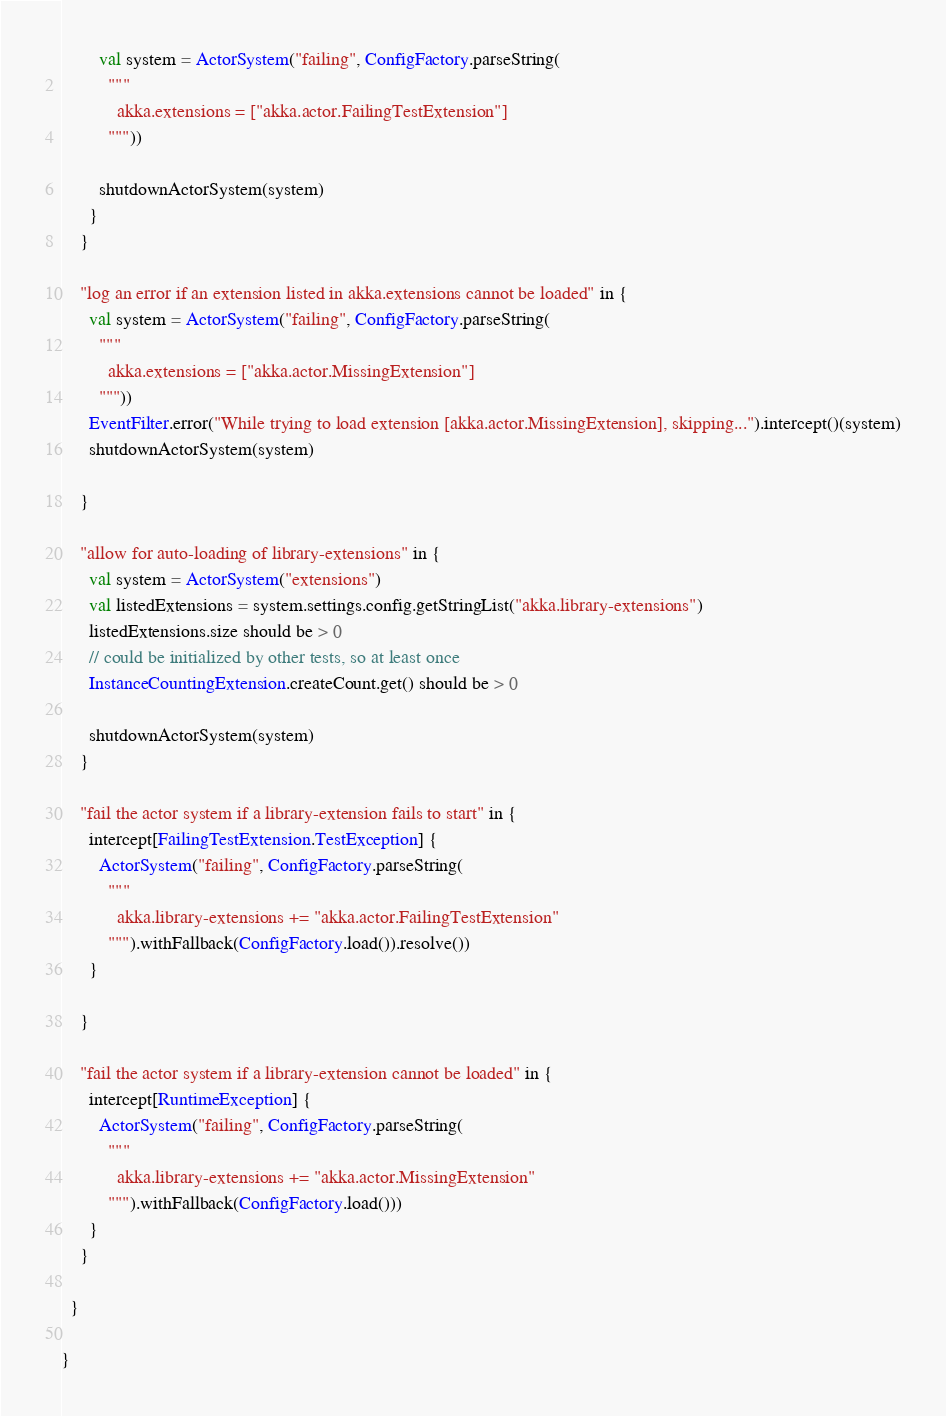<code> <loc_0><loc_0><loc_500><loc_500><_Scala_>        val system = ActorSystem("failing", ConfigFactory.parseString(
          """
            akka.extensions = ["akka.actor.FailingTestExtension"]
          """))

        shutdownActorSystem(system)
      }
    }

    "log an error if an extension listed in akka.extensions cannot be loaded" in {
      val system = ActorSystem("failing", ConfigFactory.parseString(
        """
          akka.extensions = ["akka.actor.MissingExtension"]
        """))
      EventFilter.error("While trying to load extension [akka.actor.MissingExtension], skipping...").intercept()(system)
      shutdownActorSystem(system)

    }

    "allow for auto-loading of library-extensions" in {
      val system = ActorSystem("extensions")
      val listedExtensions = system.settings.config.getStringList("akka.library-extensions")
      listedExtensions.size should be > 0
      // could be initialized by other tests, so at least once
      InstanceCountingExtension.createCount.get() should be > 0

      shutdownActorSystem(system)
    }

    "fail the actor system if a library-extension fails to start" in {
      intercept[FailingTestExtension.TestException] {
        ActorSystem("failing", ConfigFactory.parseString(
          """
            akka.library-extensions += "akka.actor.FailingTestExtension"
          """).withFallback(ConfigFactory.load()).resolve())
      }

    }

    "fail the actor system if a library-extension cannot be loaded" in {
      intercept[RuntimeException] {
        ActorSystem("failing", ConfigFactory.parseString(
          """
            akka.library-extensions += "akka.actor.MissingExtension"
          """).withFallback(ConfigFactory.load()))
      }
    }

  }

}
</code> 